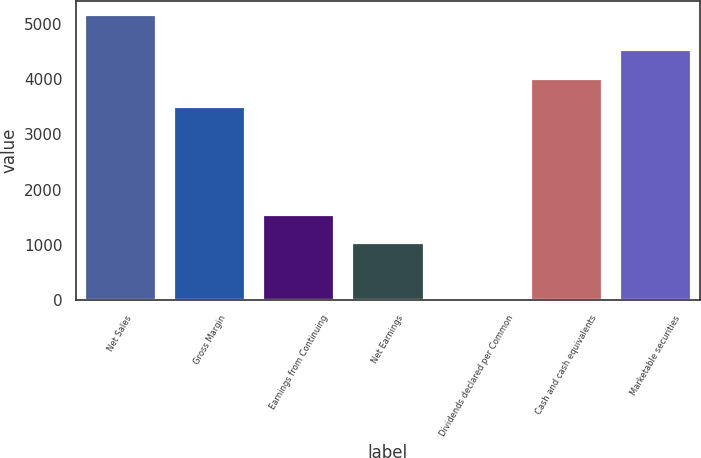Convert chart. <chart><loc_0><loc_0><loc_500><loc_500><bar_chart><fcel>Net Sales<fcel>Gross Margin<fcel>Earnings from Continuing<fcel>Net Earnings<fcel>Dividends declared per Common<fcel>Cash and cash equivalents<fcel>Marketable securities<nl><fcel>5157<fcel>3492<fcel>1547.29<fcel>1031.62<fcel>0.28<fcel>4007.67<fcel>4523.34<nl></chart> 